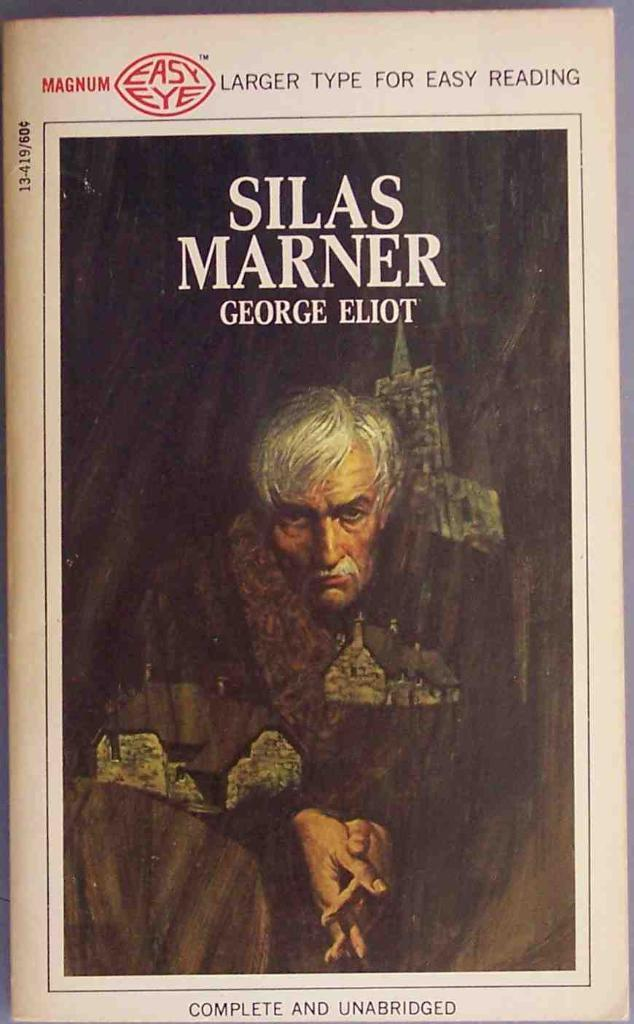Provide a one-sentence caption for the provided image. The complete and unabridged book Silas Marner is printed with larger type for easy reading. 